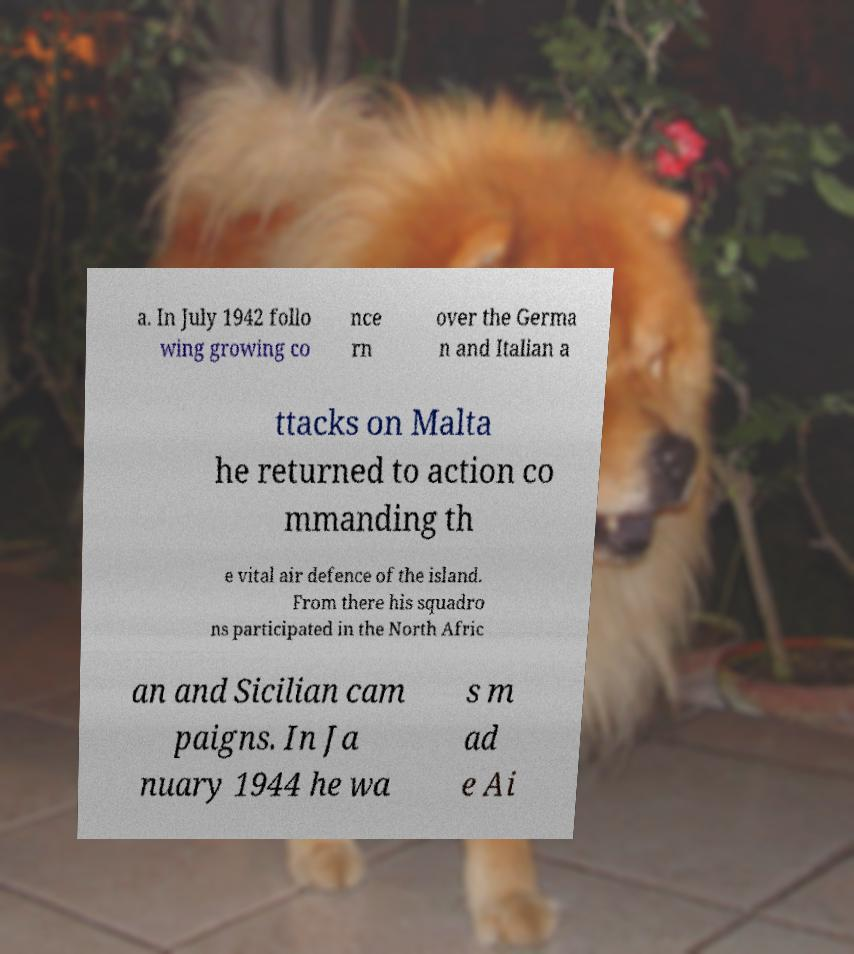Please identify and transcribe the text found in this image. a. In July 1942 follo wing growing co nce rn over the Germa n and Italian a ttacks on Malta he returned to action co mmanding th e vital air defence of the island. From there his squadro ns participated in the North Afric an and Sicilian cam paigns. In Ja nuary 1944 he wa s m ad e Ai 